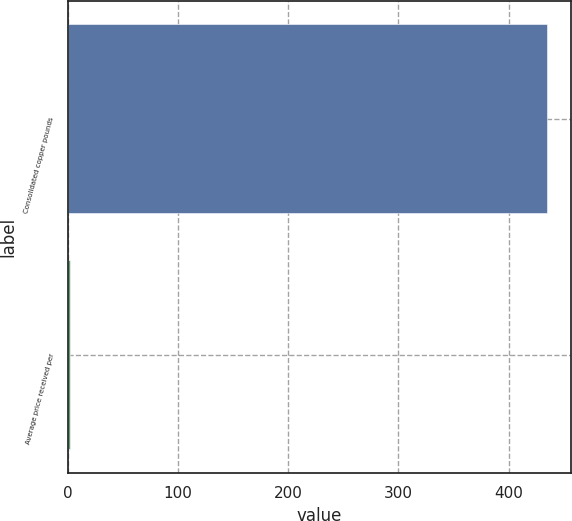<chart> <loc_0><loc_0><loc_500><loc_500><bar_chart><fcel>Consolidated copper pounds<fcel>Average price received per<nl><fcel>435<fcel>1.54<nl></chart> 